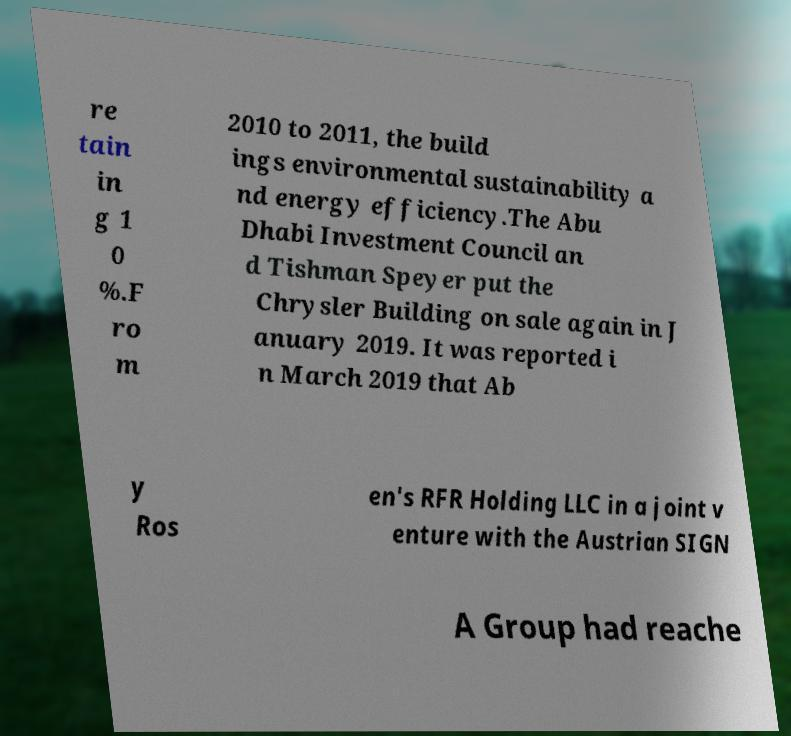Can you read and provide the text displayed in the image?This photo seems to have some interesting text. Can you extract and type it out for me? re tain in g 1 0 %.F ro m 2010 to 2011, the build ings environmental sustainability a nd energy efficiency.The Abu Dhabi Investment Council an d Tishman Speyer put the Chrysler Building on sale again in J anuary 2019. It was reported i n March 2019 that Ab y Ros en's RFR Holding LLC in a joint v enture with the Austrian SIGN A Group had reache 